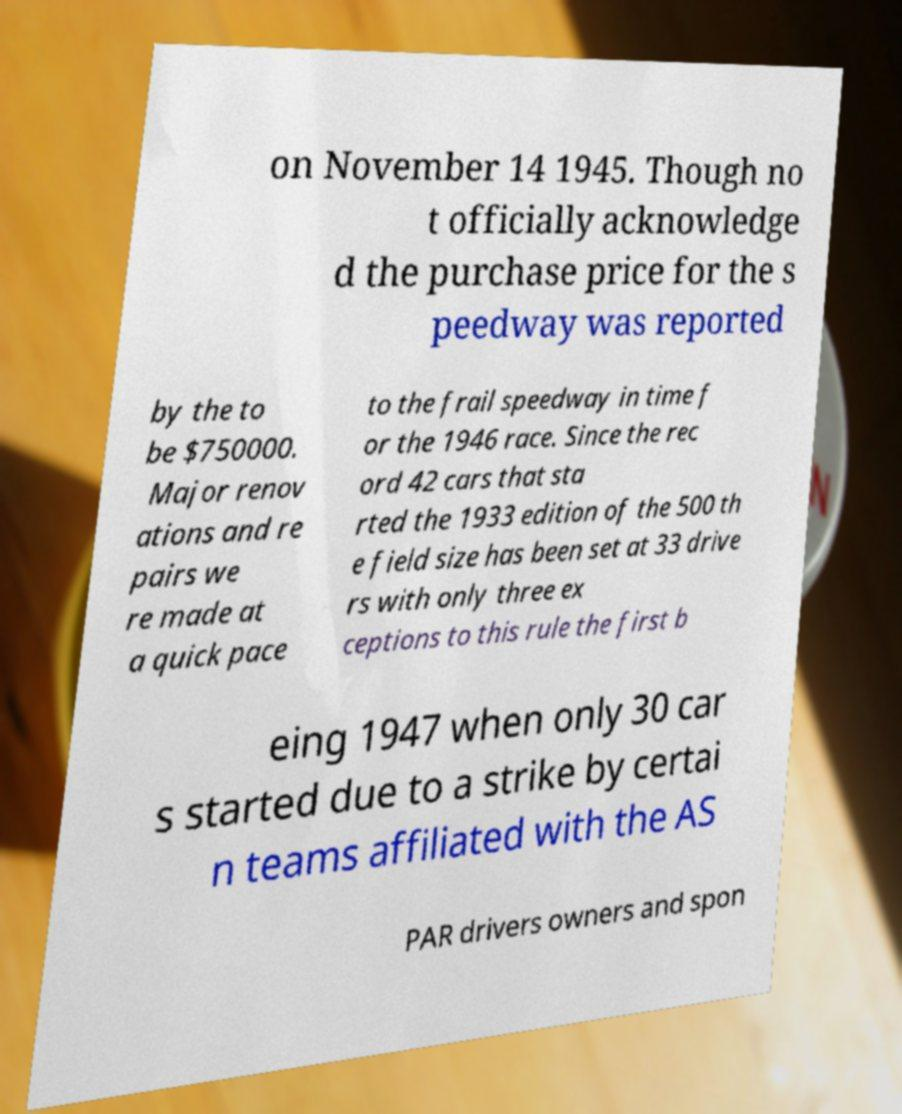Please read and relay the text visible in this image. What does it say? on November 14 1945. Though no t officially acknowledge d the purchase price for the s peedway was reported by the to be $750000. Major renov ations and re pairs we re made at a quick pace to the frail speedway in time f or the 1946 race. Since the rec ord 42 cars that sta rted the 1933 edition of the 500 th e field size has been set at 33 drive rs with only three ex ceptions to this rule the first b eing 1947 when only 30 car s started due to a strike by certai n teams affiliated with the AS PAR drivers owners and spon 